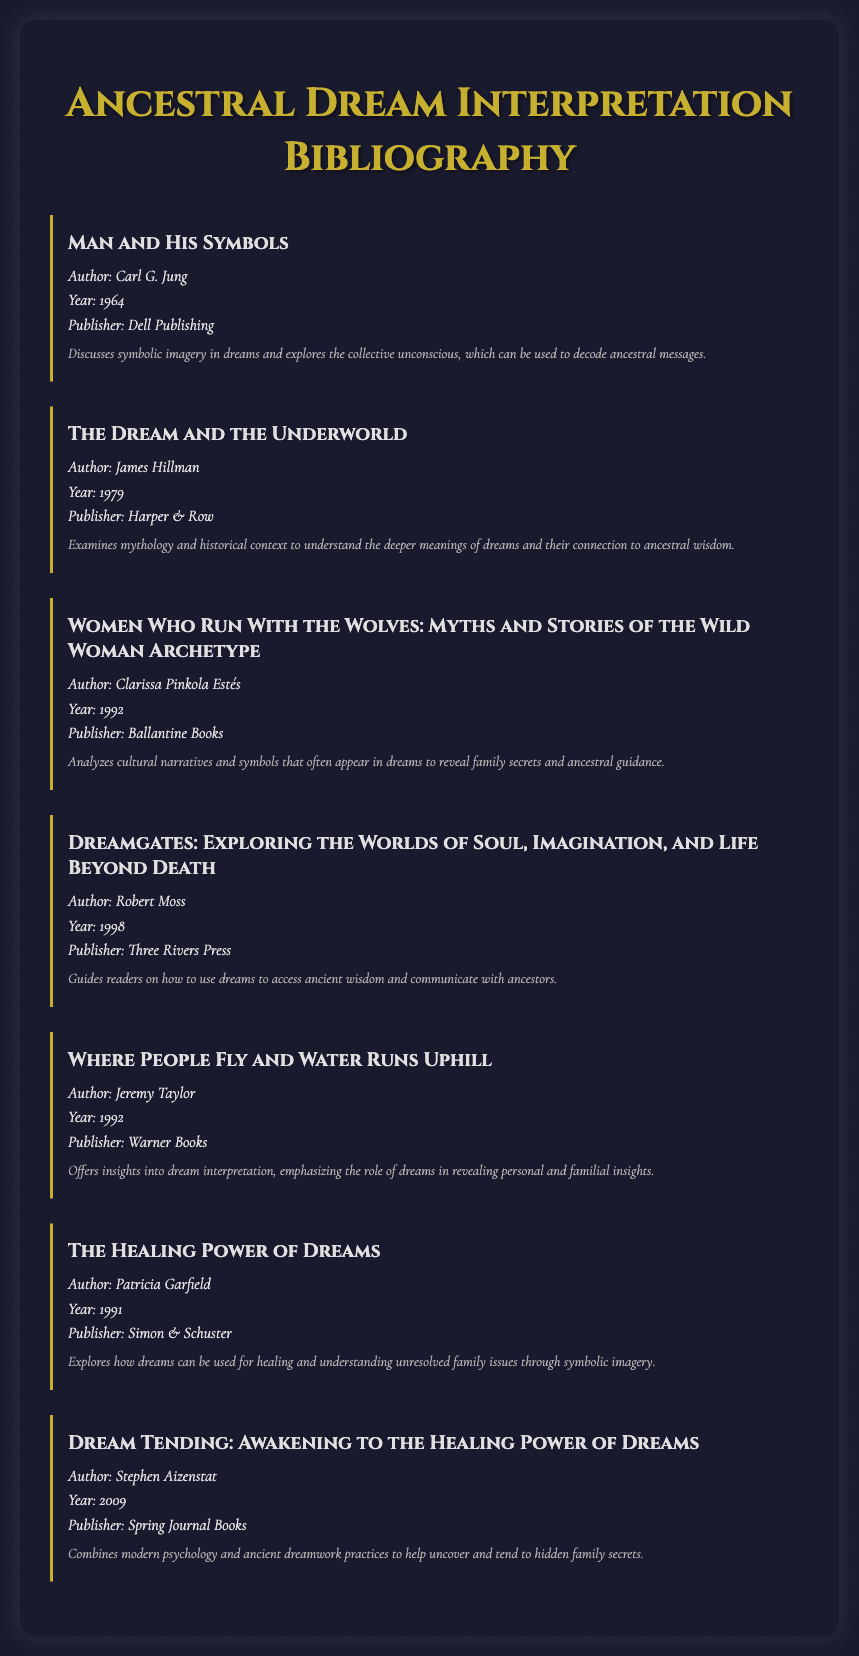What is the title of the first book listed? The title of the first book is provided at the top of its section, which is "Man and His Symbols."
Answer: Man and His Symbols Who is the author of "The Healing Power of Dreams"? The author's name is mentioned directly below the title in the document, which is Patricia Garfield.
Answer: Patricia Garfield In what year was "Women Who Run With the Wolves" published? The publication year is stated directly next to each book's title, which is 1992 for this book.
Answer: 1992 What publisher released "Dream Tending: Awakening to the Healing Power of Dreams"? The publisher's name is included in the book's information, which is Spring Journal Books.
Answer: Spring Journal Books How many books are listed in the bibliographic document? The total number of books can be counted from the sections provided, which totals to seven books.
Answer: 7 What is the primary focus of "Dreamgates: Exploring the Worlds of Soul, Imagination, and Life Beyond Death"? The focus is described in the notes section, indicating that it guides readers to use dreams for accessing ancient wisdom and communicating with ancestors.
Answer: Access ancient wisdom Which book examines mythology and historical context? The notes for the book that discusses this topic clearly mention "examines mythology and historical context," which refers to "The Dream and the Underworld."
Answer: The Dream and the Underworld What is a common theme among the listed books? Upon reviewing the notes, a recurring theme is the exploration of dreams as a means of understanding family secrets and ancestral messages.
Answer: Understanding family secrets 